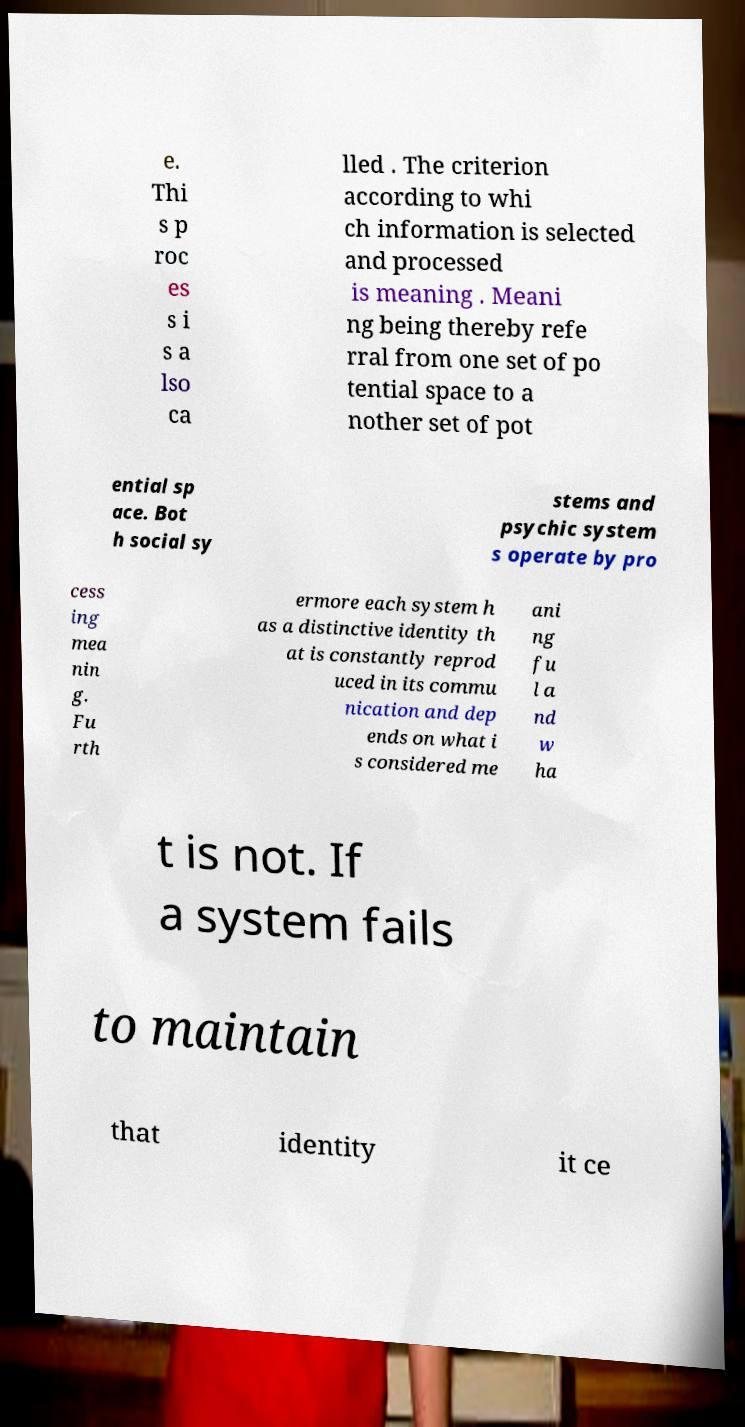For documentation purposes, I need the text within this image transcribed. Could you provide that? e. Thi s p roc es s i s a lso ca lled . The criterion according to whi ch information is selected and processed is meaning . Meani ng being thereby refe rral from one set of po tential space to a nother set of pot ential sp ace. Bot h social sy stems and psychic system s operate by pro cess ing mea nin g. Fu rth ermore each system h as a distinctive identity th at is constantly reprod uced in its commu nication and dep ends on what i s considered me ani ng fu l a nd w ha t is not. If a system fails to maintain that identity it ce 